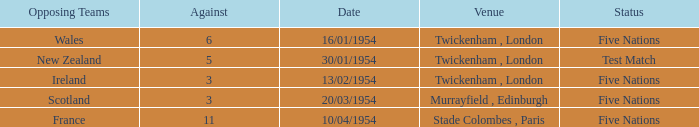What is the lowest against for games played in the stade colombes, paris venue? 11.0. 